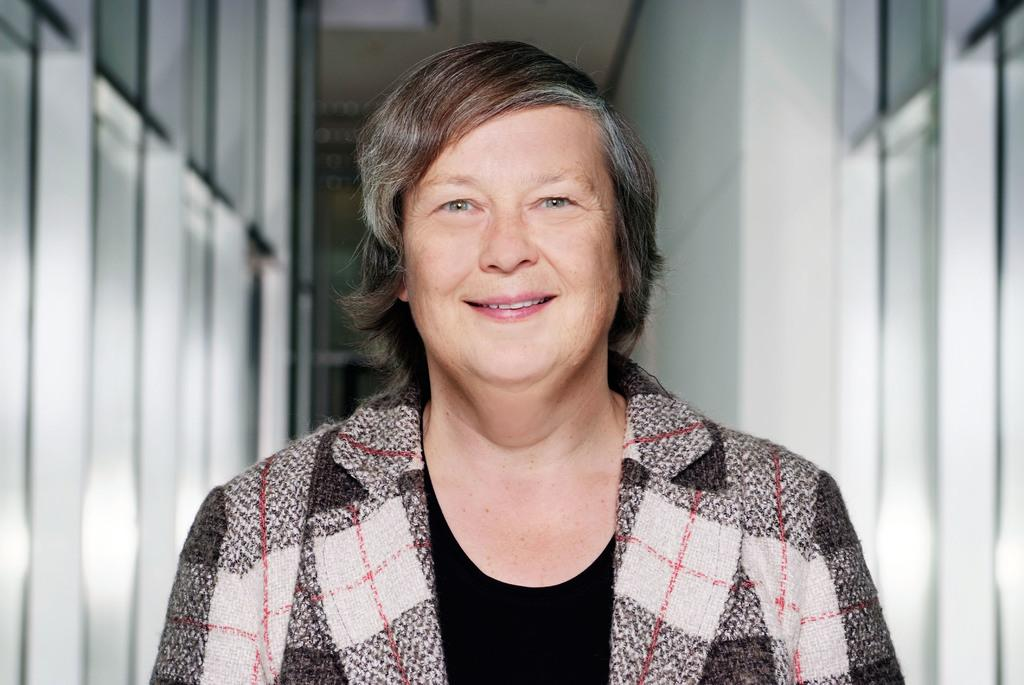Who is present in the image? There is a person in the image. What is the person's facial expression? The person is smiling. What type of clothing is the person wearing on their upper body? The person is wearing a blazer and a black t-shirt. What type of wool can be seen in the image? There is no wool present in the image. How does the fog affect the person's visibility in the image? There is no fog present in the image, so it does not affect the person's visibility. 